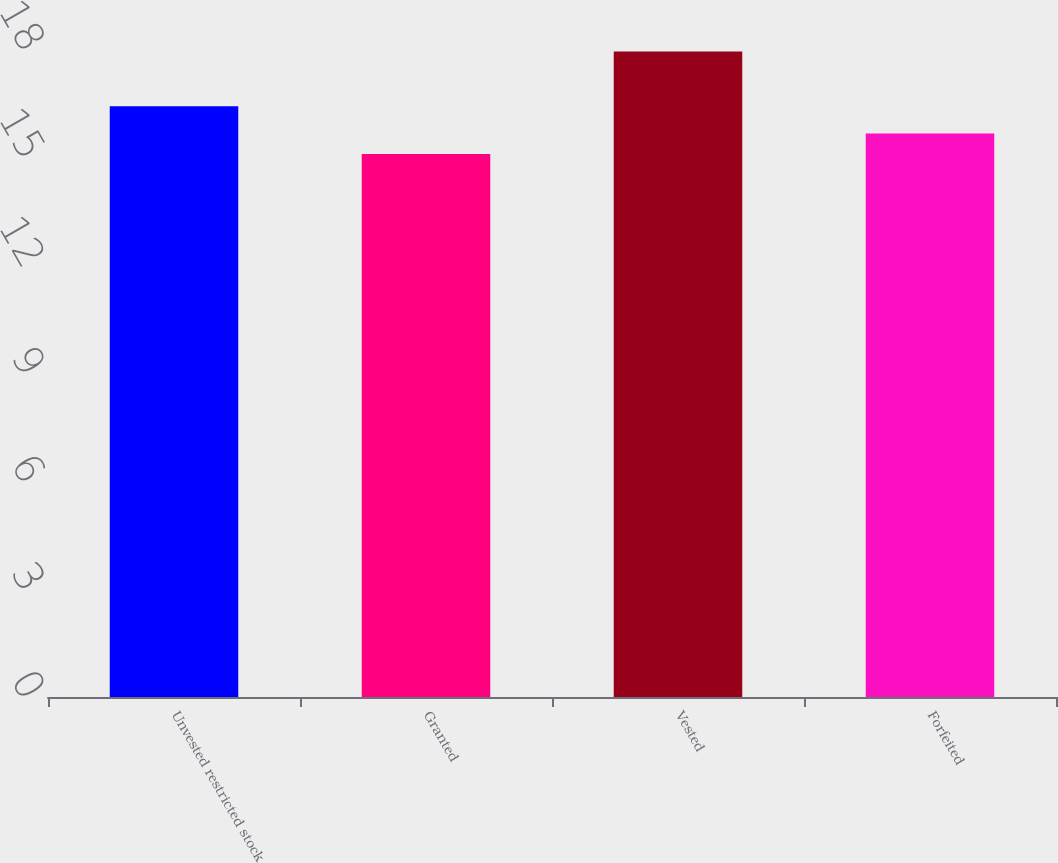Convert chart. <chart><loc_0><loc_0><loc_500><loc_500><bar_chart><fcel>Unvested restricted stock<fcel>Granted<fcel>Vested<fcel>Forfeited<nl><fcel>16.41<fcel>15.08<fcel>17.93<fcel>15.65<nl></chart> 